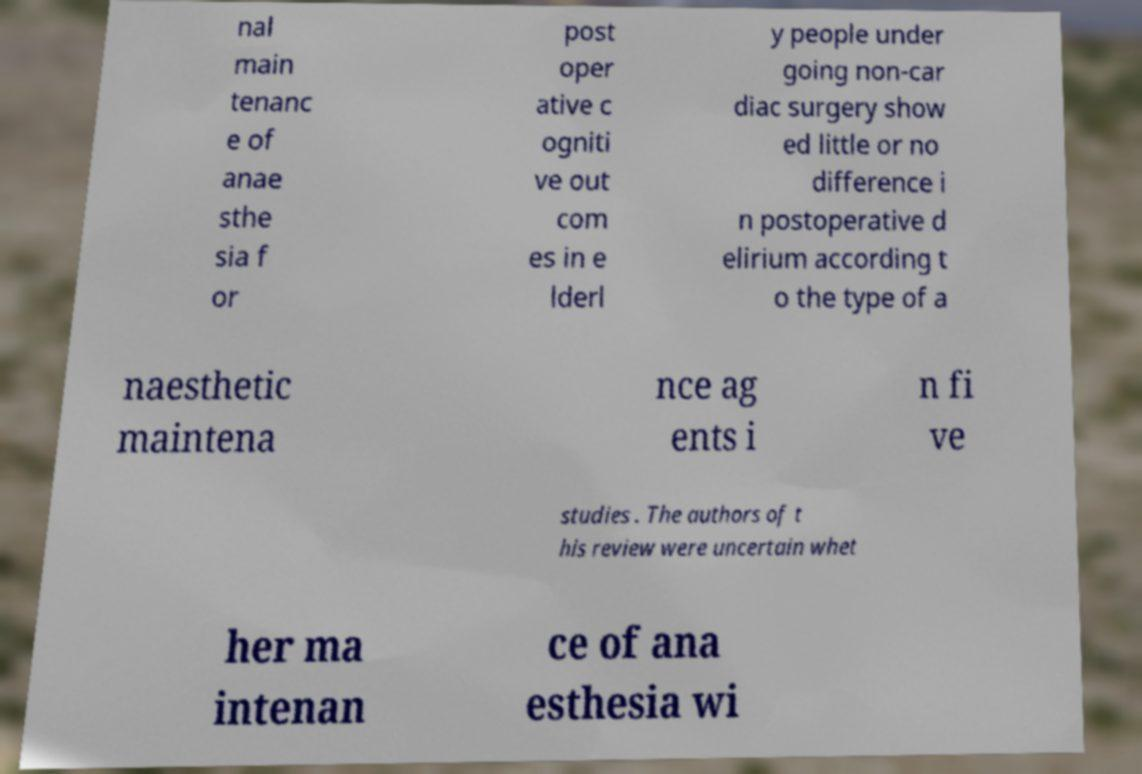Please read and relay the text visible in this image. What does it say? nal main tenanc e of anae sthe sia f or post oper ative c ogniti ve out com es in e lderl y people under going non-car diac surgery show ed little or no difference i n postoperative d elirium according t o the type of a naesthetic maintena nce ag ents i n fi ve studies . The authors of t his review were uncertain whet her ma intenan ce of ana esthesia wi 